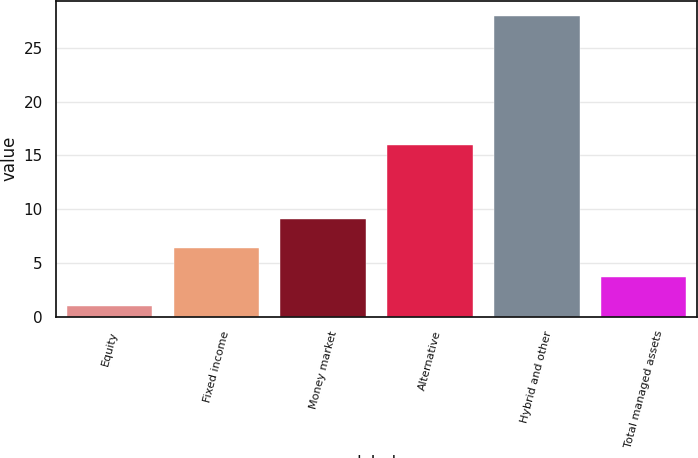Convert chart to OTSL. <chart><loc_0><loc_0><loc_500><loc_500><bar_chart><fcel>Equity<fcel>Fixed income<fcel>Money market<fcel>Alternative<fcel>Hybrid and other<fcel>Total managed assets<nl><fcel>1<fcel>6.4<fcel>9.1<fcel>16<fcel>28<fcel>3.7<nl></chart> 